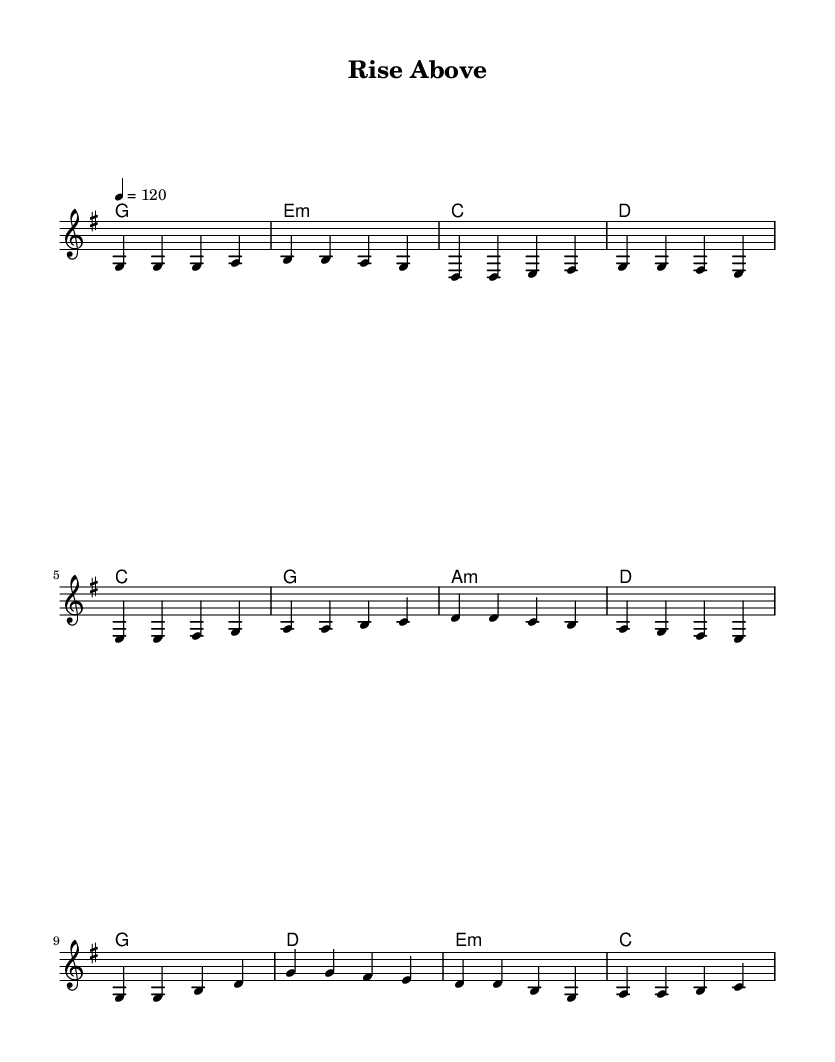What is the key signature of this music? The key signature shows one sharp, indicating that the piece is in G major.
Answer: G major What is the time signature of this piece? The time signature is indicated at the beginning as 4/4, meaning there are four beats in each measure.
Answer: 4/4 What is the tempo marking of this piece? The tempo marking states "4 = 120," which indicates that there are 120 beats per minute.
Answer: 120 How many measures are in the verse section? By counting the measures indicated for the verse, there are four measures that make up the verse section before it transitions to the pre-chorus.
Answer: 4 What is the last chord of the chorus? The chorus ends with the chord indicated as C, which is the final harmony before concluding.
Answer: C How many distinct sections does the song have? The song has three distinct sections: verse, pre-chorus, and chorus, as indicated by the structure laid out in the lyrics and music.
Answer: 3 What is the first lyrical line of the verse? The first line of the verse is "Every step you take, every move you make," as shown in the lyrics underneath the melody.
Answer: Every step you take, every move you make 